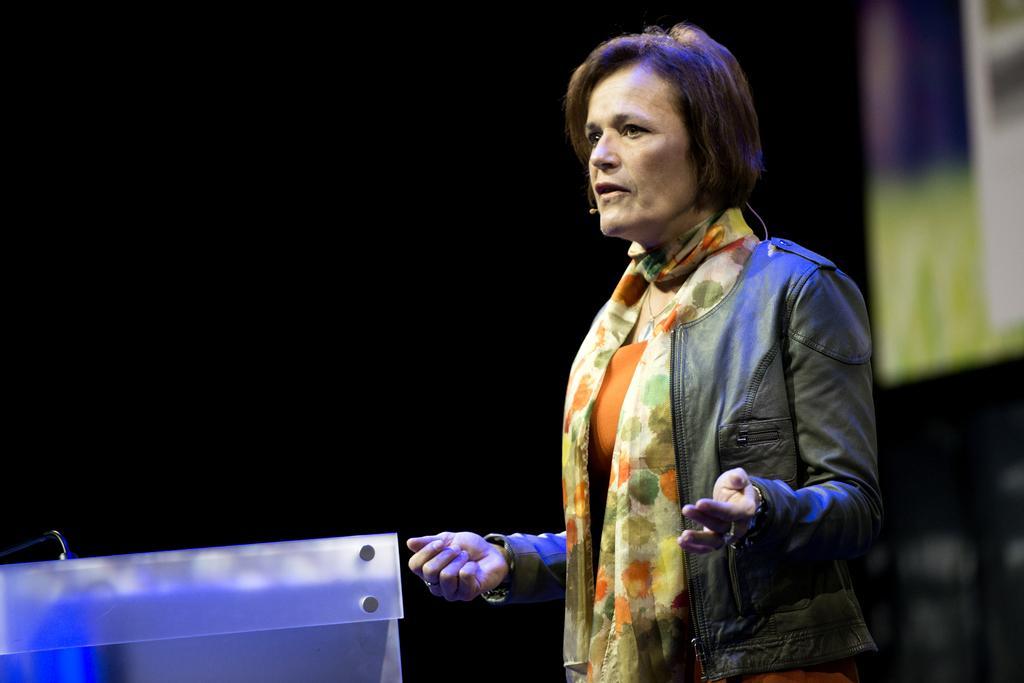Can you describe this image briefly? In this image in the center there is a woman standing and speaking. In front of the woman there is stand which is white in colour and the background is blurry. 